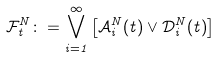<formula> <loc_0><loc_0><loc_500><loc_500>\mathcal { F } ^ { N } _ { t } \colon = \bigvee _ { i = 1 } ^ { \infty } \left [ \mathcal { A } _ { i } ^ { N } ( t ) \vee \mathcal { D } _ { i } ^ { N } ( t ) \right ]</formula> 